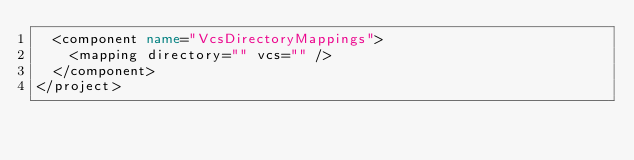Convert code to text. <code><loc_0><loc_0><loc_500><loc_500><_XML_>  <component name="VcsDirectoryMappings">
    <mapping directory="" vcs="" />
  </component>
</project>
</code> 